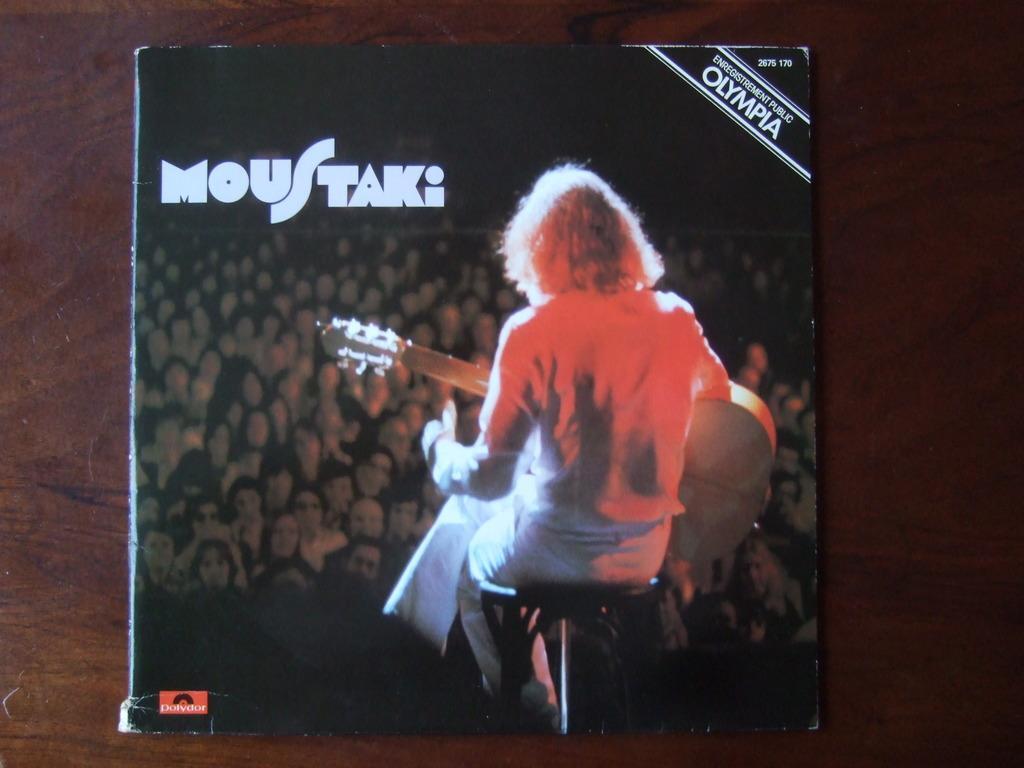Can you describe this image briefly? In this image there is a book on the wooden board, and there are words , numbers and a photo on the book. 